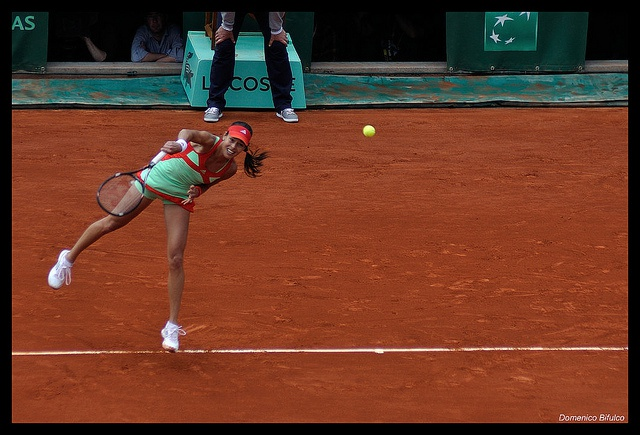Describe the objects in this image and their specific colors. I can see people in black, maroon, and brown tones, people in black, gray, maroon, and teal tones, people in black, navy, darkblue, and gray tones, tennis racket in black, brown, darkgray, and gray tones, and sports ball in black, khaki, and olive tones in this image. 